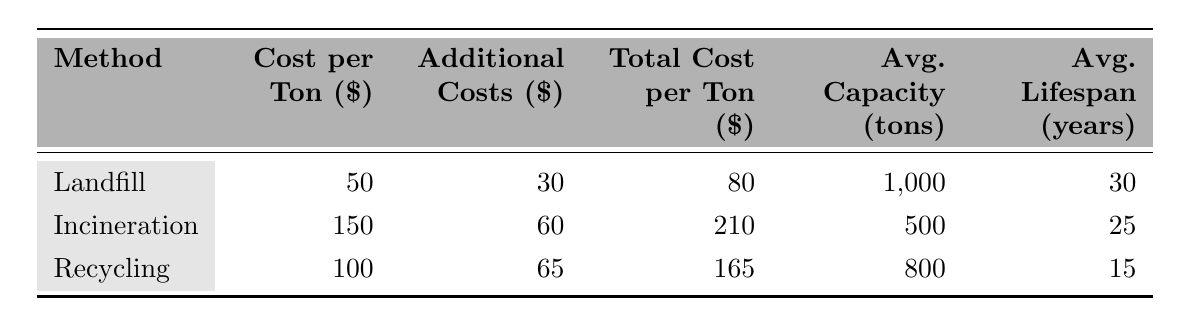What is the total cost per ton for recycling? In the table, the total cost per ton for recycling is directly stated in the last column corresponding to the recycling method. This value is 165.
Answer: 165 What is the average lifespan of incineration as a waste disposal method? The table provides the average lifespan for incineration in the last column. This value is 25 years.
Answer: 25 years Which waste disposal method has the highest total cost per ton? Comparing the total costs per ton listed in the table, incineration has the highest value at 210.
Answer: Incineration If we compare the average capacities of landfill and recycling, which one has a greater capacity? The average capacity for landfill is 1,000 tons while for recycling it is 800 tons, indicating that landfill has a greater capacity.
Answer: Landfill What is the additional cost for landfill disposal? The additional costs for landfill are listed under the respective method in the table, which sums up to 30.
Answer: 30 How much does it cost per ton to dispose of waste through incineration compared to recycling? Incineration costs 150 per ton while recycling costs 100 per ton. The difference is calculated as 150 - 100 = 50, indicating incineration is more expensive.
Answer: 50 Is the total cost per ton for landfill lower than that of recycling? The total cost per ton for landfill is 80 while for recycling it is 165. Since 80 is lower than 165, this statement is true.
Answer: True What are the additional costs associated with incineration? The additional costs for incineration, as stated in the table, are energy recovery at 20, emission control at 25, and operational maintenance at 15, totaling to 60.
Answer: 60 If we wanted to implement an environmentally friendlier option with a lower total cost, which method should we consider? The data indicates that landfill has the lowest total cost per ton at 80. Therefore, it might be considered as an option if environmental factors support its implementation.
Answer: Landfill What is the total cost per ton for landfill if we include the additional costs? The total cost per ton for landfill, including additional costs, is already provided in the table. It states 80, which encompasses the base cost and additional costs combined.
Answer: 80 